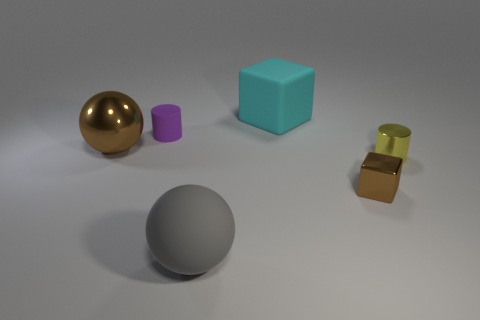What is the size of the cylinder that is behind the brown object that is left of the large matte object behind the tiny yellow shiny thing?
Ensure brevity in your answer.  Small. How many other large balls are made of the same material as the large gray sphere?
Your answer should be very brief. 0. The tiny thing that is behind the big ball behind the big matte ball is what color?
Your answer should be compact. Purple. How many objects are either large balls or tiny objects on the right side of the cyan matte object?
Provide a short and direct response. 4. Is there a metal cylinder that has the same color as the small metallic cube?
Provide a short and direct response. No. How many blue things are metal cubes or small objects?
Provide a succinct answer. 0. How many other things are the same size as the gray sphere?
Ensure brevity in your answer.  2. How many big things are either brown shiny cubes or green rubber spheres?
Provide a succinct answer. 0. Does the gray ball have the same size as the cube in front of the shiny sphere?
Make the answer very short. No. There is a large object that is the same material as the cyan cube; what shape is it?
Keep it short and to the point. Sphere. 